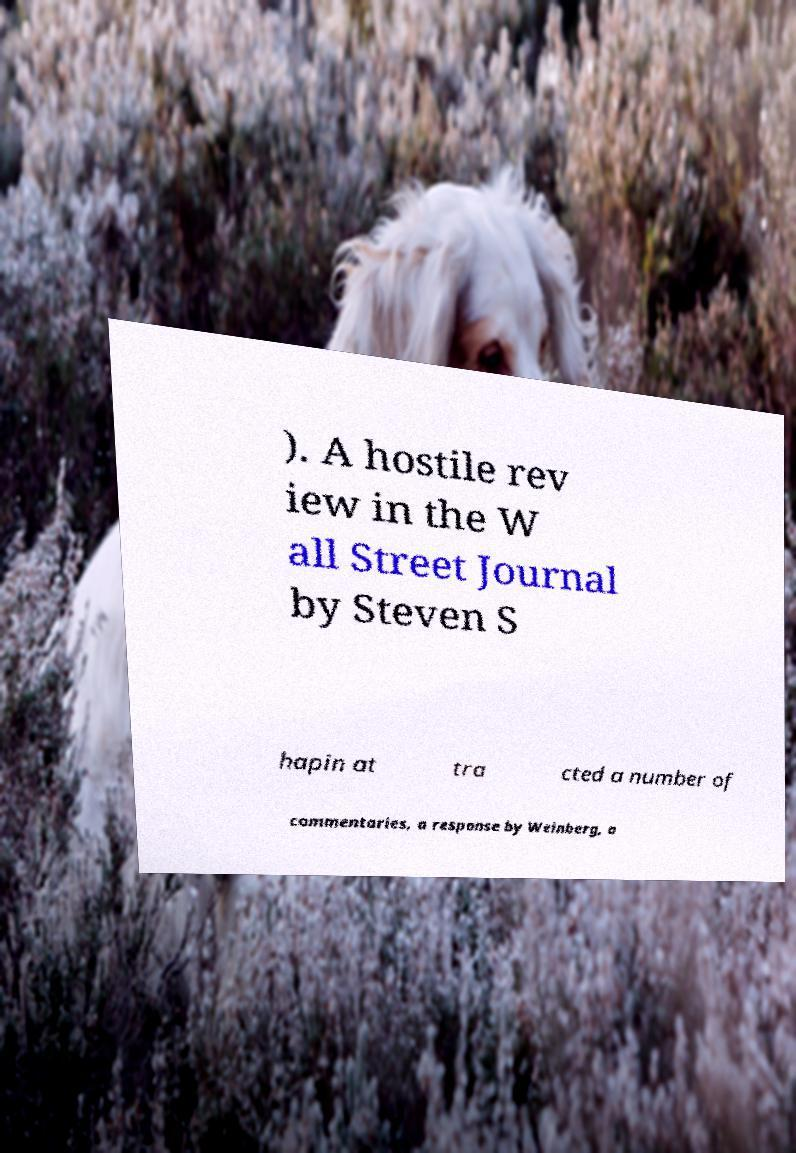Please identify and transcribe the text found in this image. ). A hostile rev iew in the W all Street Journal by Steven S hapin at tra cted a number of commentaries, a response by Weinberg, a 